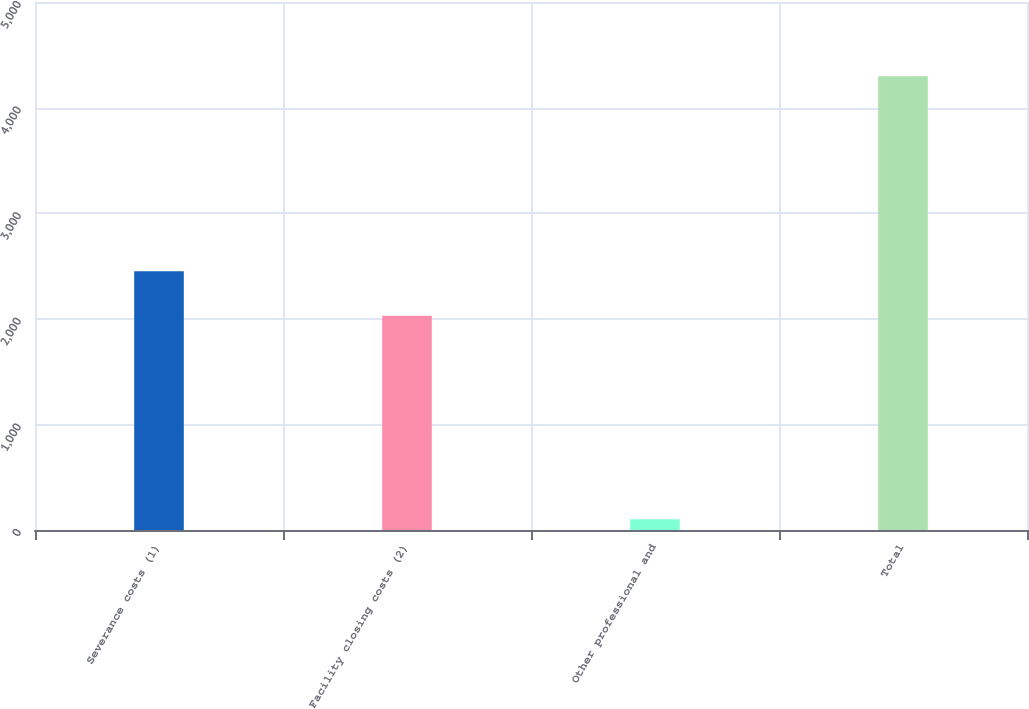Convert chart to OTSL. <chart><loc_0><loc_0><loc_500><loc_500><bar_chart><fcel>Severance costs (1)<fcel>Facility closing costs (2)<fcel>Other professional and<fcel>Total<nl><fcel>2449.5<fcel>2030<fcel>102<fcel>4297<nl></chart> 